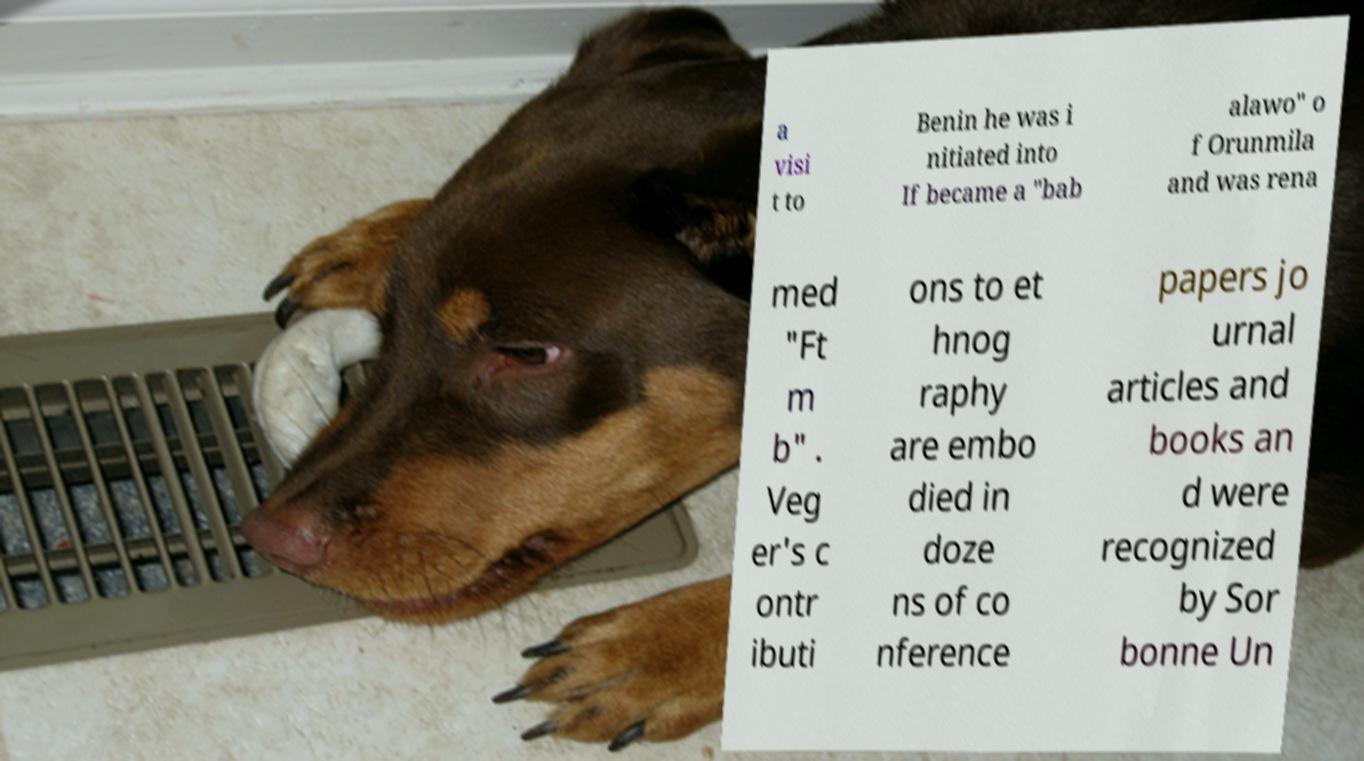Can you read and provide the text displayed in the image?This photo seems to have some interesting text. Can you extract and type it out for me? a visi t to Benin he was i nitiated into If became a "bab alawo" o f Orunmila and was rena med "Ft m b" . Veg er's c ontr ibuti ons to et hnog raphy are embo died in doze ns of co nference papers jo urnal articles and books an d were recognized by Sor bonne Un 